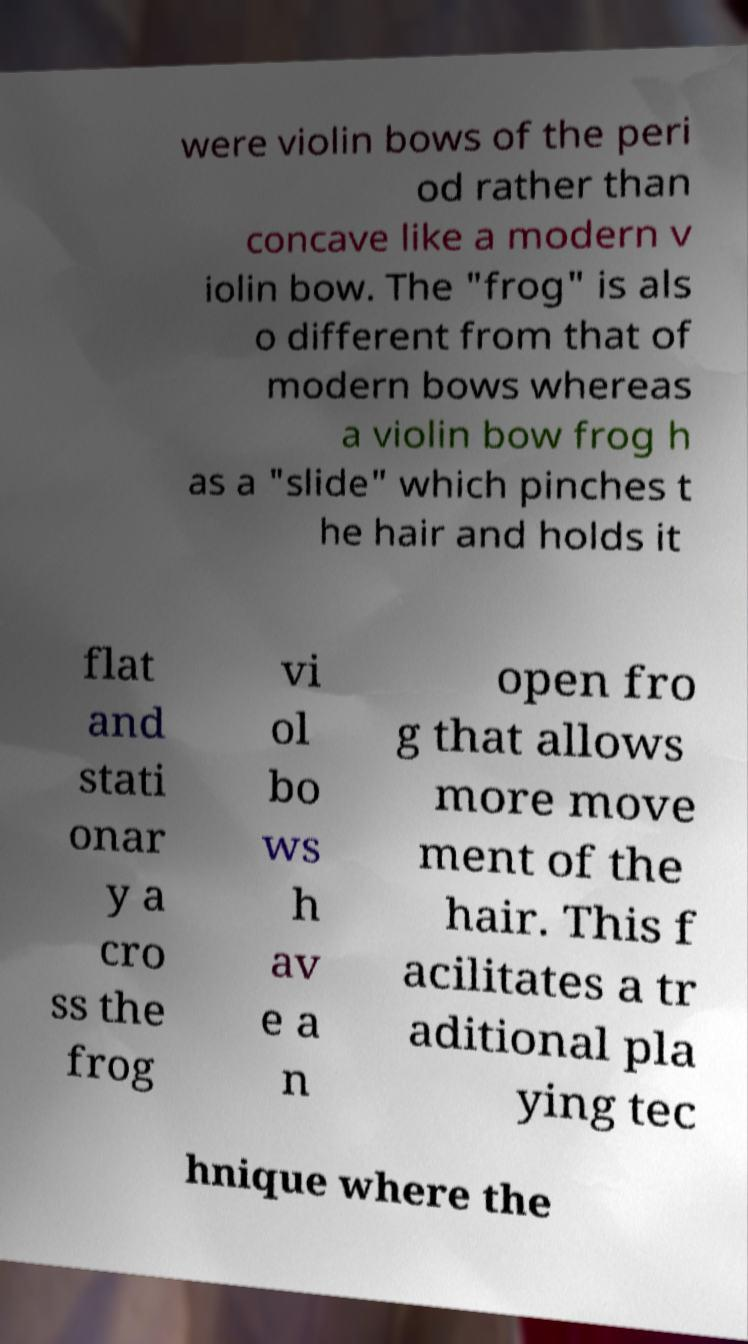Please read and relay the text visible in this image. What does it say? were violin bows of the peri od rather than concave like a modern v iolin bow. The "frog" is als o different from that of modern bows whereas a violin bow frog h as a "slide" which pinches t he hair and holds it flat and stati onar y a cro ss the frog vi ol bo ws h av e a n open fro g that allows more move ment of the hair. This f acilitates a tr aditional pla ying tec hnique where the 